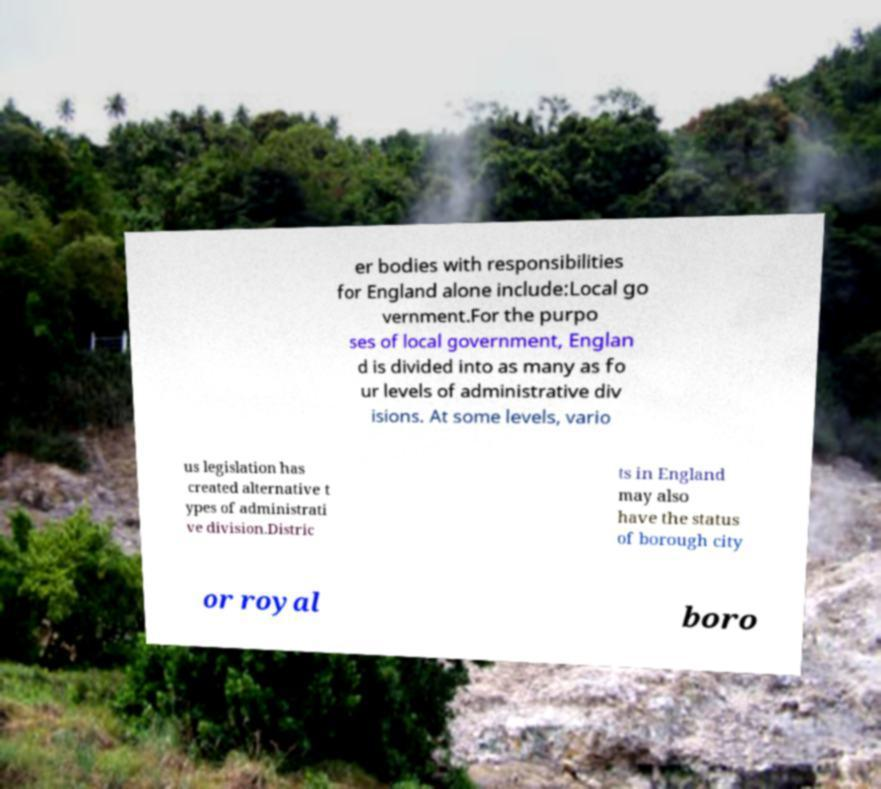Can you read and provide the text displayed in the image?This photo seems to have some interesting text. Can you extract and type it out for me? er bodies with responsibilities for England alone include:Local go vernment.For the purpo ses of local government, Englan d is divided into as many as fo ur levels of administrative div isions. At some levels, vario us legislation has created alternative t ypes of administrati ve division.Distric ts in England may also have the status of borough city or royal boro 